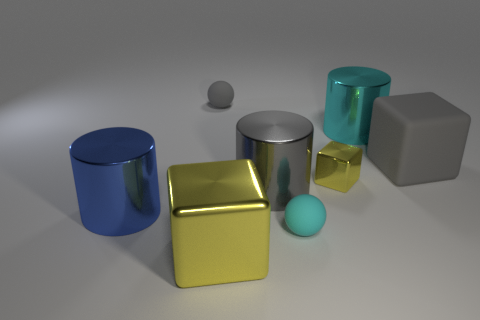What number of tiny red balls are there?
Ensure brevity in your answer.  0. What number of spheres are either large yellow objects or blue metallic things?
Your answer should be compact. 0. What number of small balls are behind the gray matte thing that is in front of the cyan thing that is behind the gray cube?
Your response must be concise. 1. What color is the shiny block that is the same size as the gray sphere?
Make the answer very short. Yellow. How many other objects are the same color as the big metal cube?
Provide a succinct answer. 1. Is the number of blue things that are to the right of the big matte cube greater than the number of big cyan metal cubes?
Give a very brief answer. No. Are the tiny gray sphere and the big yellow object made of the same material?
Your response must be concise. No. How many things are either big metal cylinders behind the small yellow block or shiny things?
Provide a succinct answer. 5. How many other objects are there of the same size as the blue metallic cylinder?
Give a very brief answer. 4. Are there an equal number of cyan balls behind the tiny gray rubber sphere and large gray matte things behind the big cyan cylinder?
Make the answer very short. Yes. 